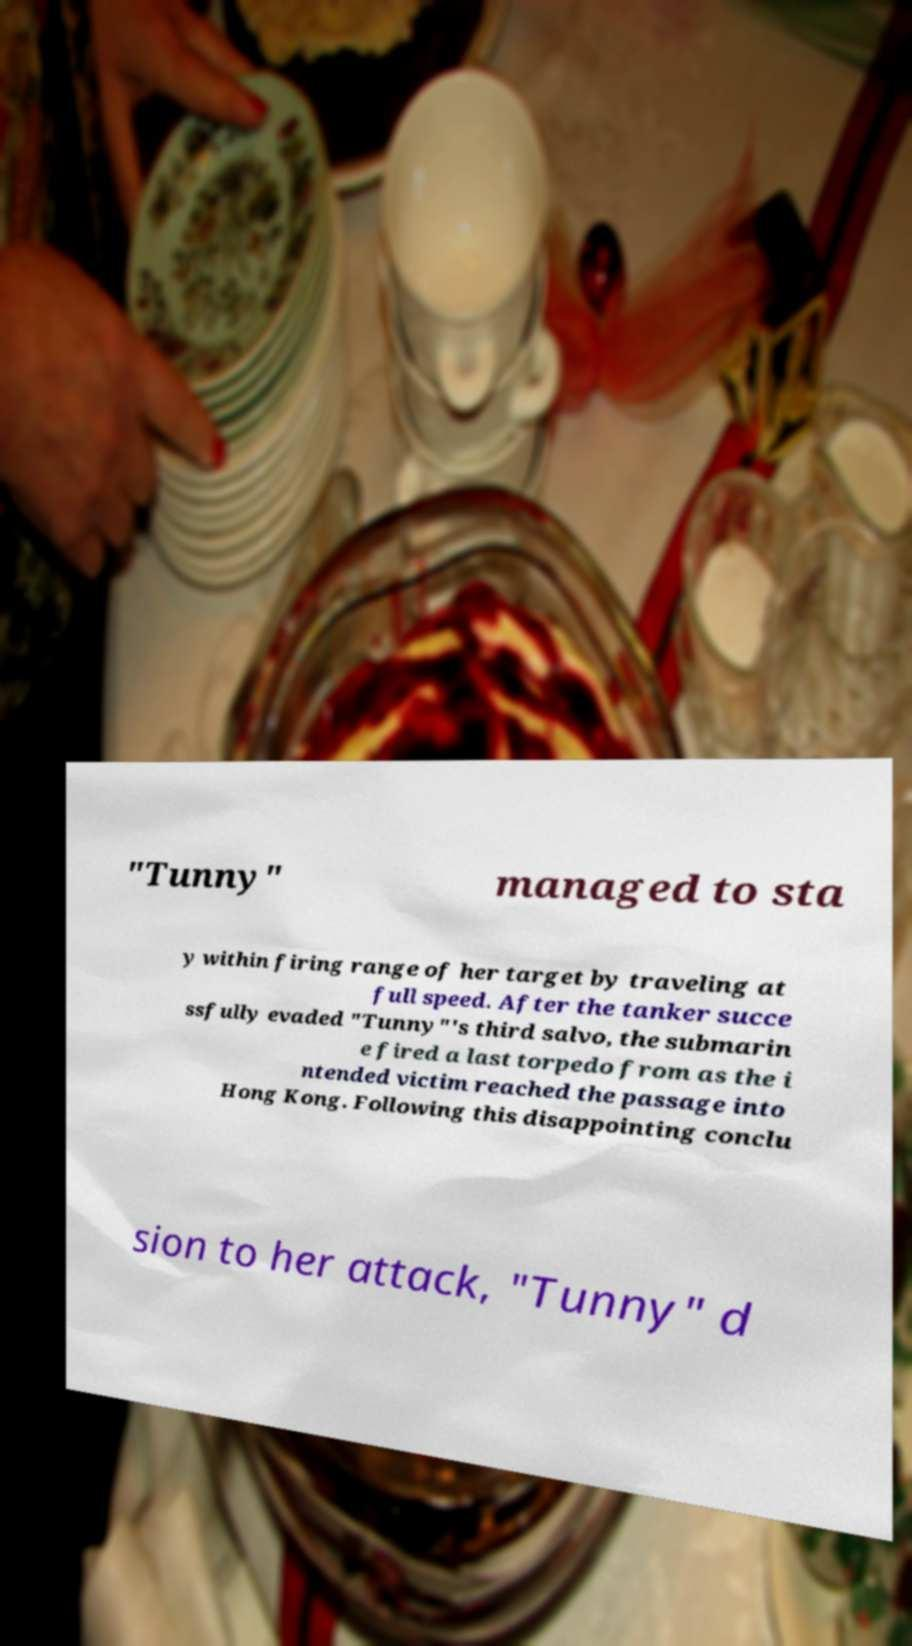What messages or text are displayed in this image? I need them in a readable, typed format. "Tunny" managed to sta y within firing range of her target by traveling at full speed. After the tanker succe ssfully evaded "Tunny"'s third salvo, the submarin e fired a last torpedo from as the i ntended victim reached the passage into Hong Kong. Following this disappointing conclu sion to her attack, "Tunny" d 